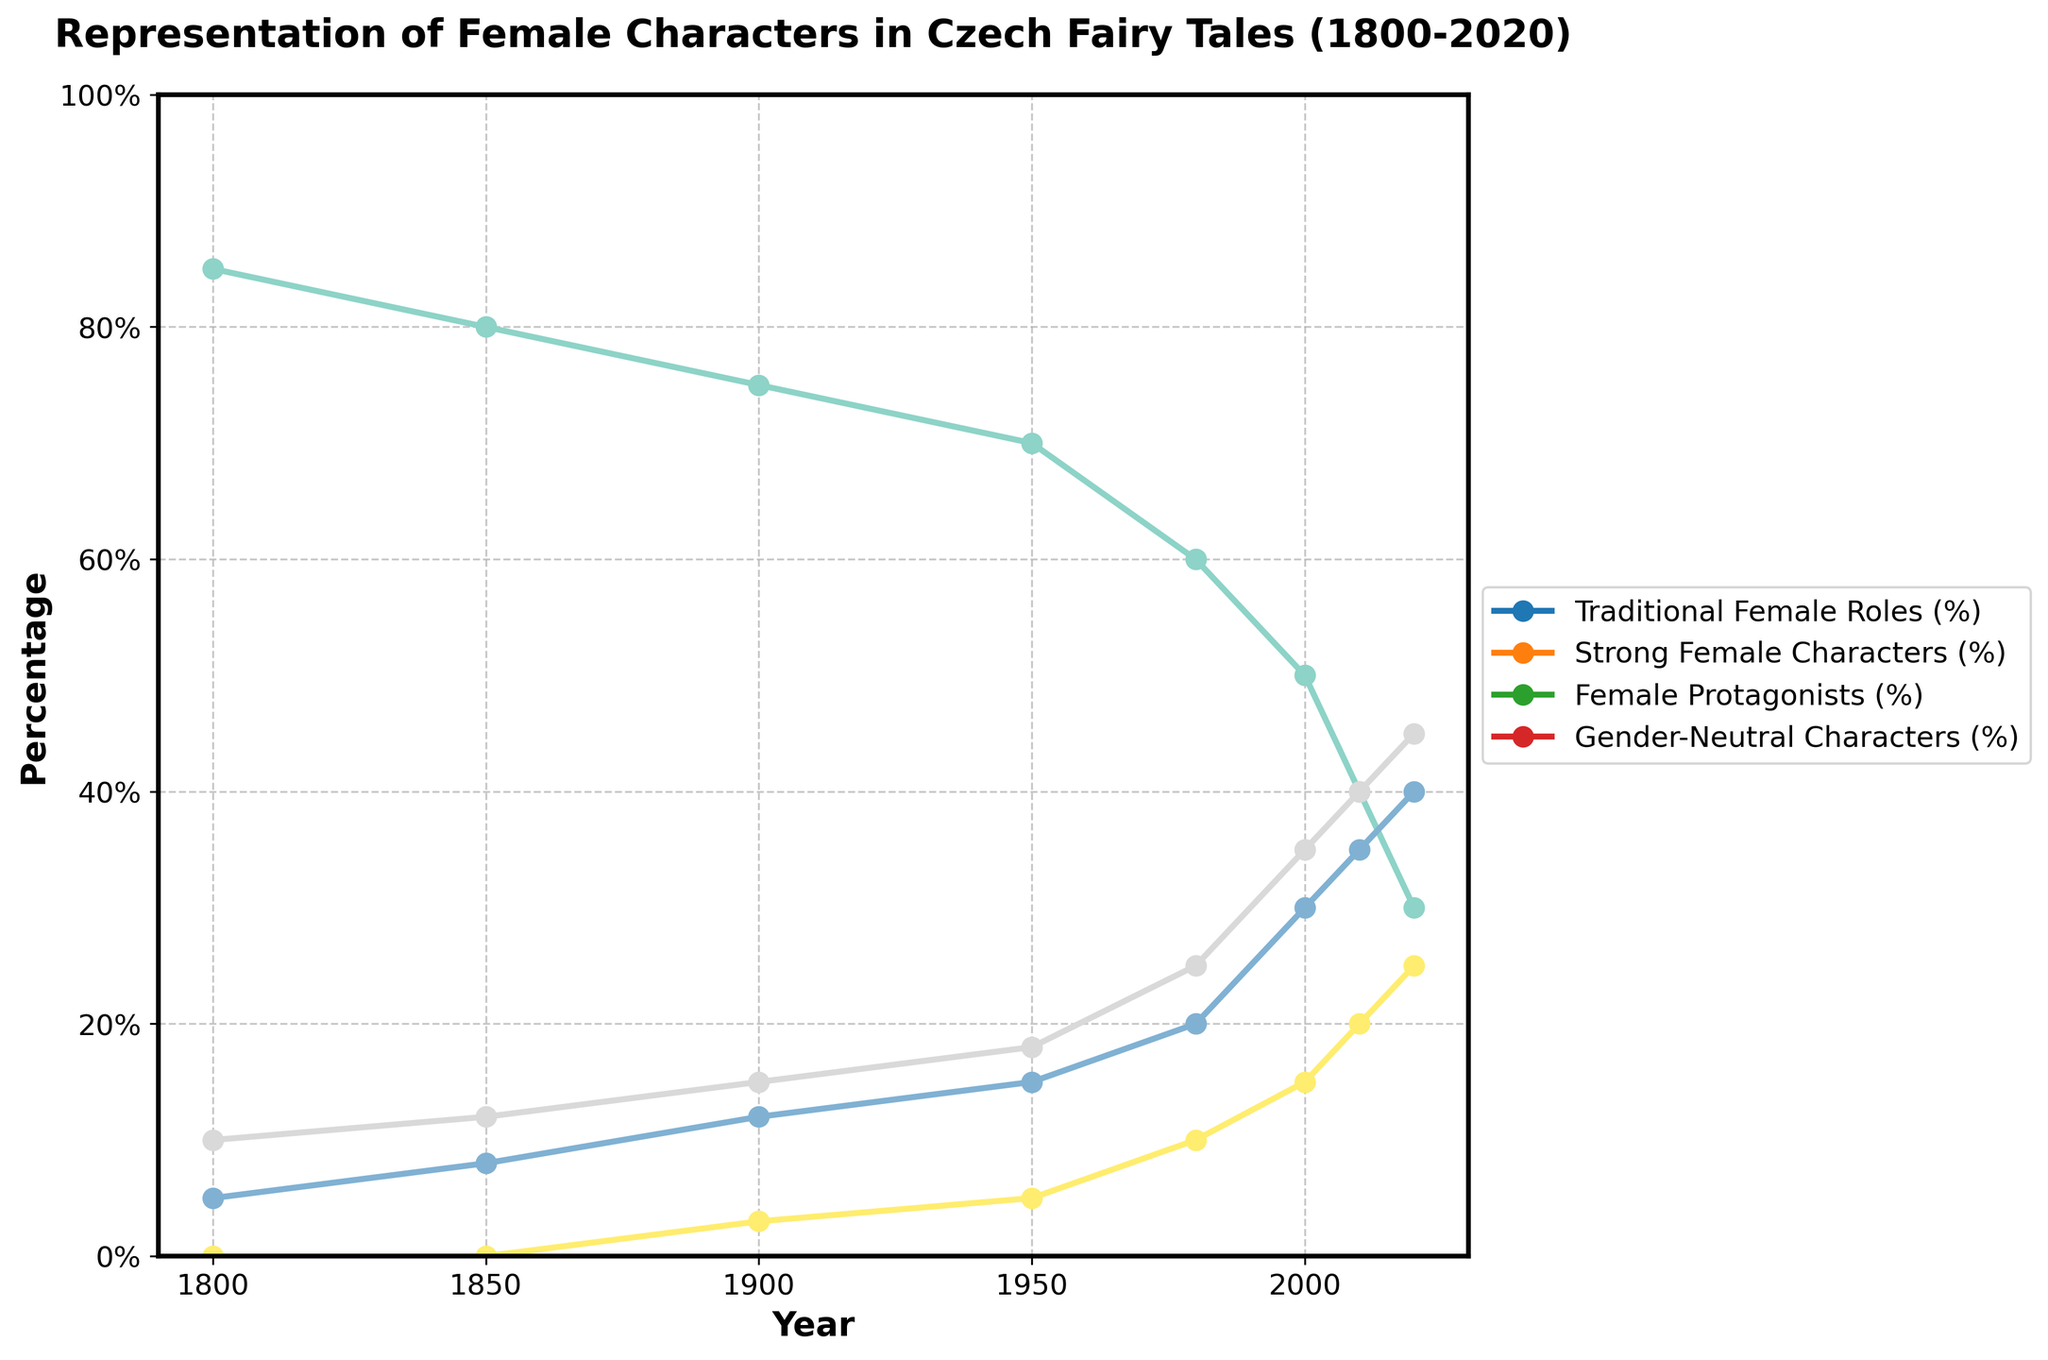How does the percentage of traditional female roles in 1800 compare to 2020? In 1800, traditional female roles are at 85%, while in 2020 they are at 30%. The difference is 55%.
Answer: The percentage decreased by 55% Which year shows the highest percentage of strong female characters? By looking at the line representing strong female characters, the highest point was in 2020, with 40%.
Answer: 2020 What is the sum of percentages for female protagonists and gender-neutral characters in 2000? For 2000, female protagonists are 35% and gender-neutral characters are 15%. The sum is 35% + 15% = 50%.
Answer: 50% Between which two decades is there the greatest increase in the percentage of female protagonists? The percentage of female protagonists increases the most from 1980 (25%) to 2000 (35%), which is a difference of 10%.
Answer: 1980 to 2000 Compare the trend of traditional female roles and strong female characters from 1850 to 1950. From 1850 to 1950, traditional female roles decrease from 80% to 70%, and strong female characters increase from 8% to 15%. Both trends show a traditional decline and strong character increase.
Answer: Traditional roles decrease, strong characters increase What is the average percentage of gender-neutral characters across all the years? Adding the percentages of gender-neutral characters: 0 + 0 + 3 + 5 + 10 + 15 + 20 + 25 = 78%, and dividing by 8 years, the average is 78% / 8 = 9.75%.
Answer: 9.75% In which period did traditional female roles see a sharp decline and how can it be identified visually? Traditional female roles decreased sharply between 1980 (60%) and 2000 (50%) by 10%, which is visually identified by the steep slope in the line plot.
Answer: 1980-2000 Which two categories have crossed paths the most times in the given period? Female Protagonists and Strong Female characters cross over in the years around 2000 and 2010, visually identifiable by their lines intersecting twice in that period.
Answer: Female Protagonists and Strong Female Characters How much did the percentage of female protagonists increase between 1950 and 2020? In 1950, female protagonists were 18%, and by 2020, they were 45%. The increase is 45% - 18% = 27%.
Answer: 27% What is the general trend of gender-neutral characters from 1800 to 2020? Gender-neutral characters were 0% in 1800 and gradually increased to 25% by 2020. This can be seen by the upward trend in the line graph over time.
Answer: Increasing trend 